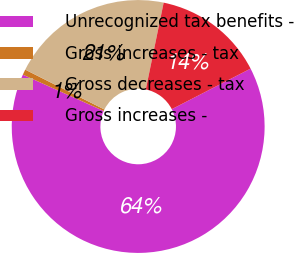Convert chart to OTSL. <chart><loc_0><loc_0><loc_500><loc_500><pie_chart><fcel>Unrecognized tax benefits -<fcel>Gross increases - tax<fcel>Gross decreases - tax<fcel>Gross increases -<nl><fcel>64.29%<fcel>0.7%<fcel>20.81%<fcel>14.2%<nl></chart> 